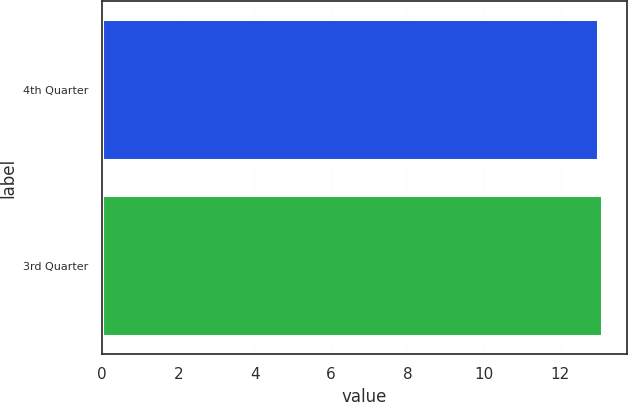<chart> <loc_0><loc_0><loc_500><loc_500><bar_chart><fcel>4th Quarter<fcel>3rd Quarter<nl><fcel>13<fcel>13.1<nl></chart> 